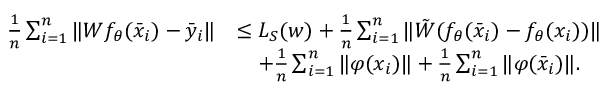<formula> <loc_0><loc_0><loc_500><loc_500>\begin{array} { r l } { \frac { 1 } { n } \sum _ { i = 1 } ^ { n } \| W f _ { \theta } ( { \bar { x } } _ { i } ) - { \bar { y } } _ { i } \| } & { \leq L _ { S } ( w ) + \frac { 1 } { n } \sum _ { i = 1 } ^ { n } \| { \tilde { W } } ( f _ { \theta } ( { \bar { x } } _ { i } ) - f _ { \theta } ( x _ { i } ) ) \| } \\ & { \quad + \frac { 1 } { n } \sum _ { i = 1 } ^ { n } \| \varphi ( x _ { i } ) \| + \frac { 1 } { n } \sum _ { i = 1 } ^ { n } \| \varphi ( { \bar { x } } _ { i } ) \| . } \end{array}</formula> 